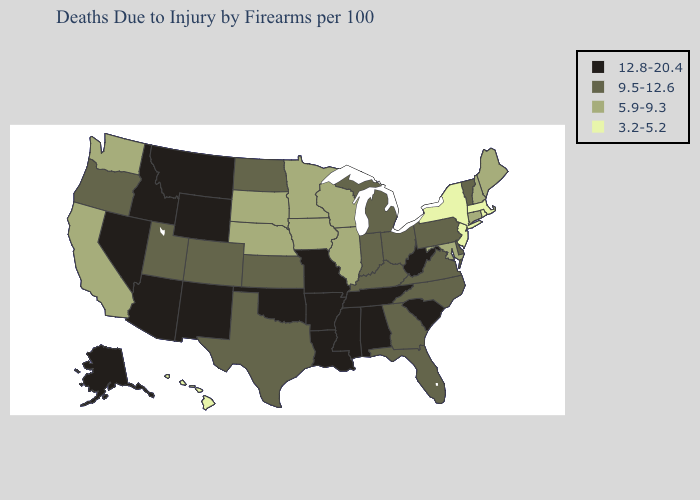Among the states that border Alabama , does Tennessee have the highest value?
Short answer required. Yes. Name the states that have a value in the range 12.8-20.4?
Give a very brief answer. Alabama, Alaska, Arizona, Arkansas, Idaho, Louisiana, Mississippi, Missouri, Montana, Nevada, New Mexico, Oklahoma, South Carolina, Tennessee, West Virginia, Wyoming. Name the states that have a value in the range 5.9-9.3?
Concise answer only. California, Connecticut, Illinois, Iowa, Maine, Maryland, Minnesota, Nebraska, New Hampshire, South Dakota, Washington, Wisconsin. Among the states that border North Dakota , does Montana have the highest value?
Write a very short answer. Yes. Does the first symbol in the legend represent the smallest category?
Answer briefly. No. What is the highest value in states that border Montana?
Write a very short answer. 12.8-20.4. Among the states that border Alabama , which have the highest value?
Concise answer only. Mississippi, Tennessee. Which states have the highest value in the USA?
Write a very short answer. Alabama, Alaska, Arizona, Arkansas, Idaho, Louisiana, Mississippi, Missouri, Montana, Nevada, New Mexico, Oklahoma, South Carolina, Tennessee, West Virginia, Wyoming. Is the legend a continuous bar?
Quick response, please. No. Does the map have missing data?
Short answer required. No. What is the highest value in states that border Colorado?
Answer briefly. 12.8-20.4. Does Hawaii have the same value as Massachusetts?
Keep it brief. Yes. How many symbols are there in the legend?
Be succinct. 4. Does the map have missing data?
Answer briefly. No. Name the states that have a value in the range 12.8-20.4?
Answer briefly. Alabama, Alaska, Arizona, Arkansas, Idaho, Louisiana, Mississippi, Missouri, Montana, Nevada, New Mexico, Oklahoma, South Carolina, Tennessee, West Virginia, Wyoming. 